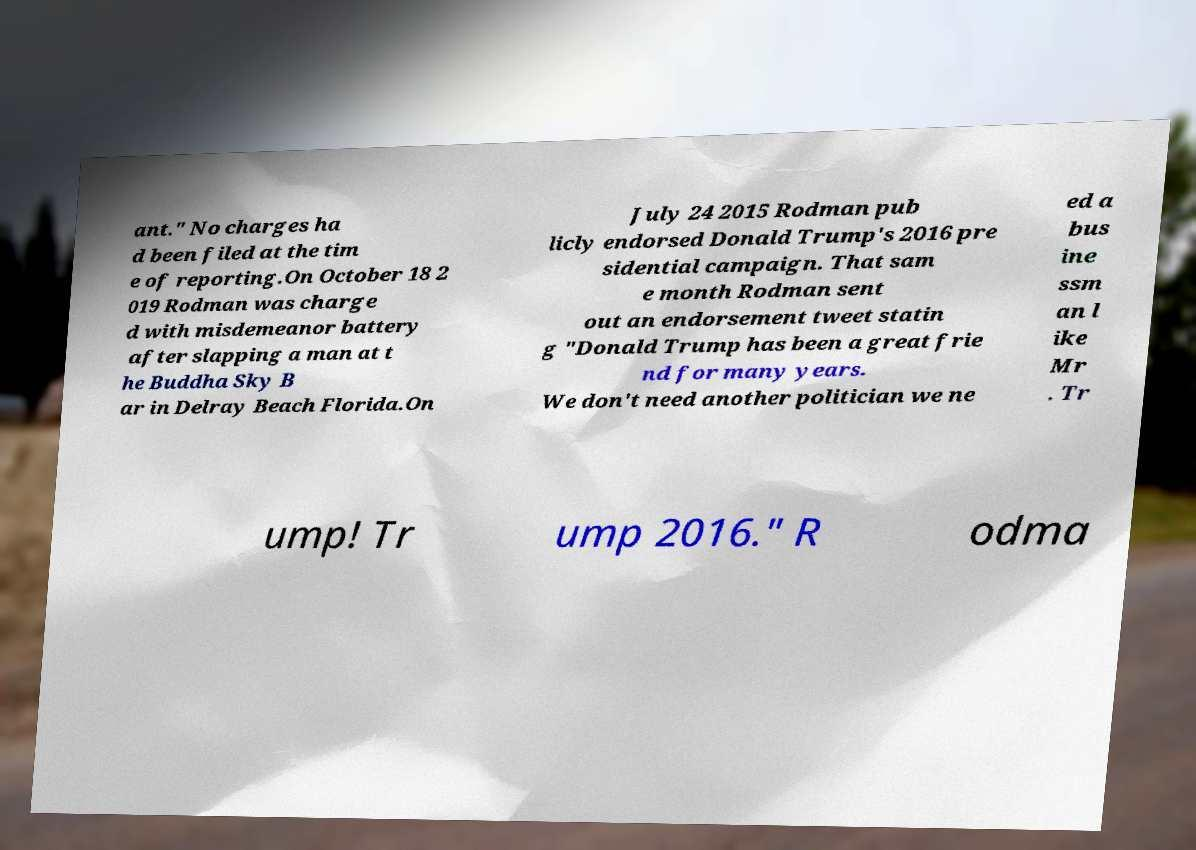Could you extract and type out the text from this image? ant." No charges ha d been filed at the tim e of reporting.On October 18 2 019 Rodman was charge d with misdemeanor battery after slapping a man at t he Buddha Sky B ar in Delray Beach Florida.On July 24 2015 Rodman pub licly endorsed Donald Trump's 2016 pre sidential campaign. That sam e month Rodman sent out an endorsement tweet statin g "Donald Trump has been a great frie nd for many years. We don't need another politician we ne ed a bus ine ssm an l ike Mr . Tr ump! Tr ump 2016." R odma 